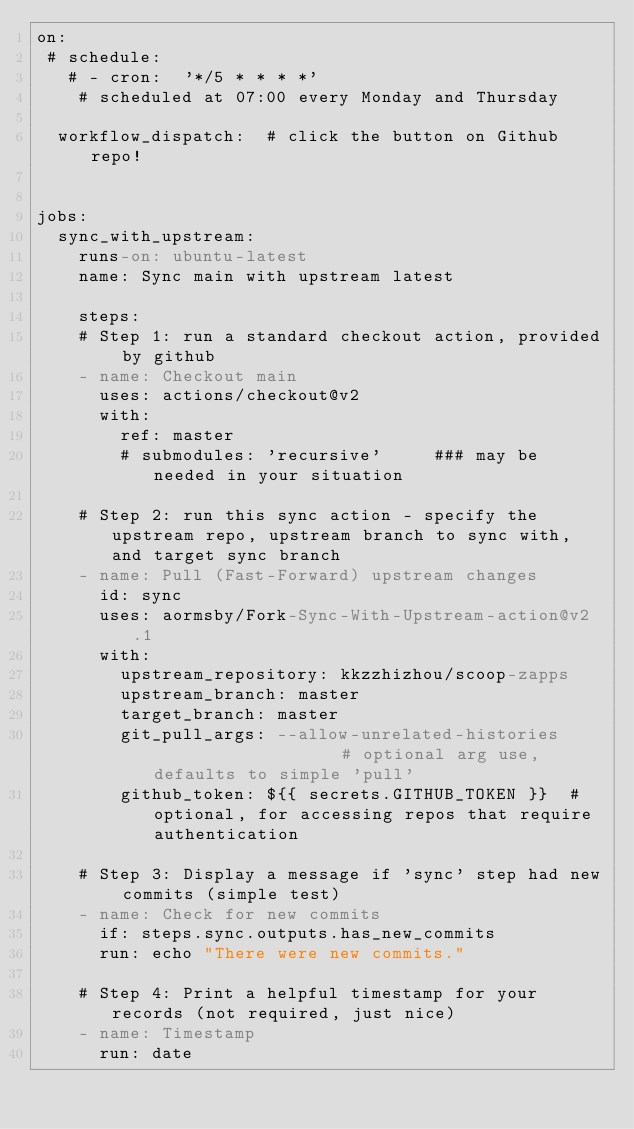<code> <loc_0><loc_0><loc_500><loc_500><_YAML_>on:
 # schedule:
   # - cron:  '*/5 * * * *'
    # scheduled at 07:00 every Monday and Thursday

  workflow_dispatch:  # click the button on Github repo!


jobs:
  sync_with_upstream:
    runs-on: ubuntu-latest
    name: Sync main with upstream latest

    steps:
    # Step 1: run a standard checkout action, provided by github
    - name: Checkout main
      uses: actions/checkout@v2
      with:
        ref: master
        # submodules: 'recursive'     ### may be needed in your situation

    # Step 2: run this sync action - specify the upstream repo, upstream branch to sync with, and target sync branch
    - name: Pull (Fast-Forward) upstream changes
      id: sync
      uses: aormsby/Fork-Sync-With-Upstream-action@v2.1
      with:
        upstream_repository: kkzzhizhou/scoop-zapps
        upstream_branch: master
        target_branch: master
        git_pull_args: --allow-unrelated-histories                   # optional arg use, defaults to simple 'pull'
        github_token: ${{ secrets.GITHUB_TOKEN }}  # optional, for accessing repos that require authentication

    # Step 3: Display a message if 'sync' step had new commits (simple test)
    - name: Check for new commits
      if: steps.sync.outputs.has_new_commits
      run: echo "There were new commits."

    # Step 4: Print a helpful timestamp for your records (not required, just nice)
    - name: Timestamp
      run: date
</code> 